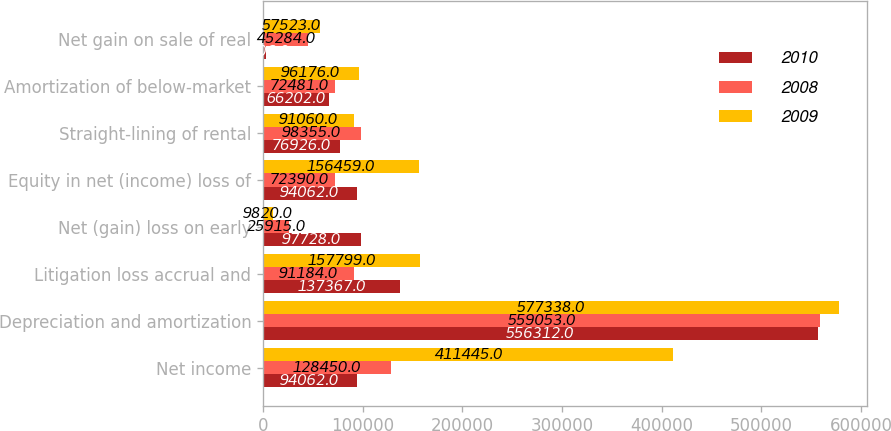<chart> <loc_0><loc_0><loc_500><loc_500><stacked_bar_chart><ecel><fcel>Net income<fcel>Depreciation and amortization<fcel>Litigation loss accrual and<fcel>Net (gain) loss on early<fcel>Equity in net (income) loss of<fcel>Straight-lining of rental<fcel>Amortization of below-market<fcel>Net gain on sale of real<nl><fcel>2010<fcel>94062<fcel>556312<fcel>137367<fcel>97728<fcel>94062<fcel>76926<fcel>66202<fcel>2506<nl><fcel>2008<fcel>128450<fcel>559053<fcel>91184<fcel>25915<fcel>72390<fcel>98355<fcel>72481<fcel>45284<nl><fcel>2009<fcel>411445<fcel>577338<fcel>157799<fcel>9820<fcel>156459<fcel>91060<fcel>96176<fcel>57523<nl></chart> 